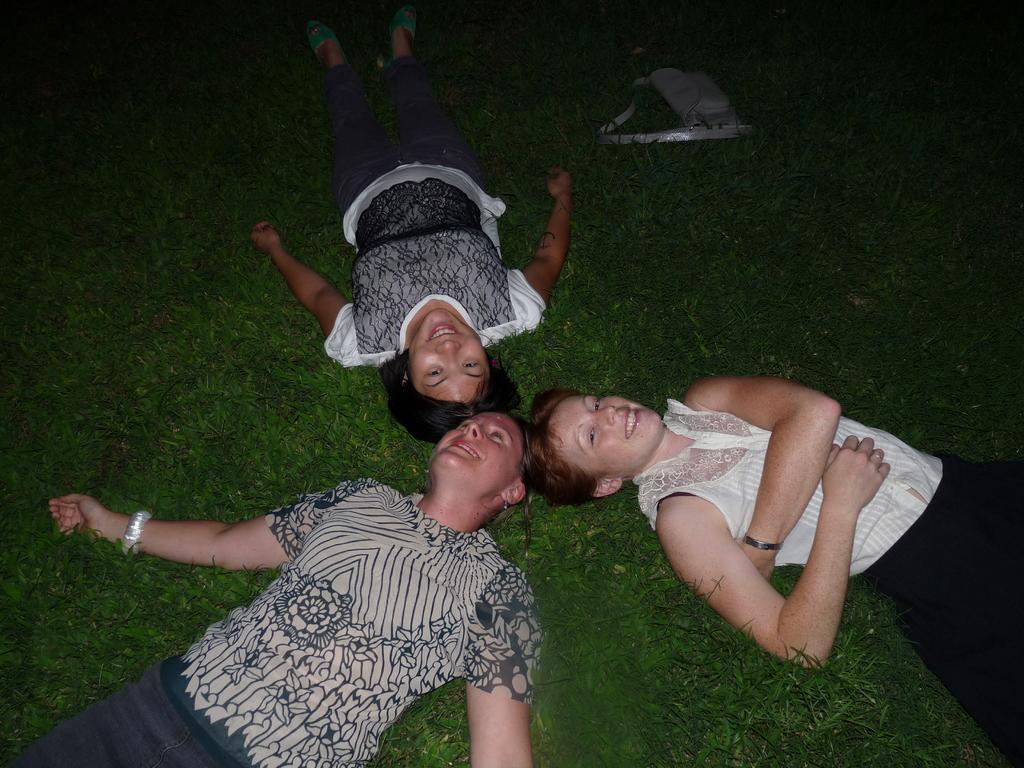How would you summarize this image in a sentence or two? In this image, we can see three persons lying on the grass. At the top of the image, we can see a bag on the grass. 